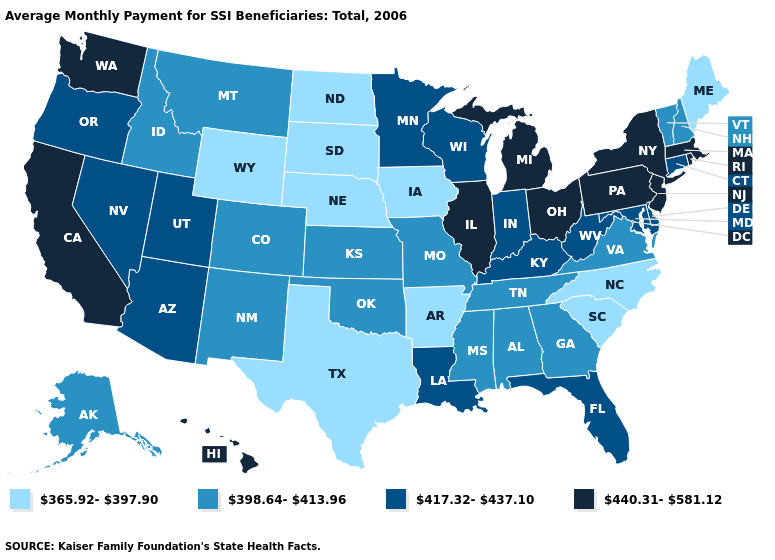What is the value of Maryland?
Short answer required. 417.32-437.10. What is the value of Florida?
Be succinct. 417.32-437.10. Does Florida have the same value as Tennessee?
Short answer required. No. What is the value of New Mexico?
Concise answer only. 398.64-413.96. Among the states that border Virginia , which have the highest value?
Be succinct. Kentucky, Maryland, West Virginia. Name the states that have a value in the range 365.92-397.90?
Answer briefly. Arkansas, Iowa, Maine, Nebraska, North Carolina, North Dakota, South Carolina, South Dakota, Texas, Wyoming. Does New Mexico have a higher value than Connecticut?
Short answer required. No. Name the states that have a value in the range 417.32-437.10?
Concise answer only. Arizona, Connecticut, Delaware, Florida, Indiana, Kentucky, Louisiana, Maryland, Minnesota, Nevada, Oregon, Utah, West Virginia, Wisconsin. What is the value of North Carolina?
Short answer required. 365.92-397.90. What is the lowest value in the USA?
Concise answer only. 365.92-397.90. How many symbols are there in the legend?
Be succinct. 4. Does Tennessee have the highest value in the USA?
Be succinct. No. Does New Mexico have the highest value in the USA?
Write a very short answer. No. Does Arkansas have a lower value than Wyoming?
Write a very short answer. No. What is the value of Kansas?
Concise answer only. 398.64-413.96. 